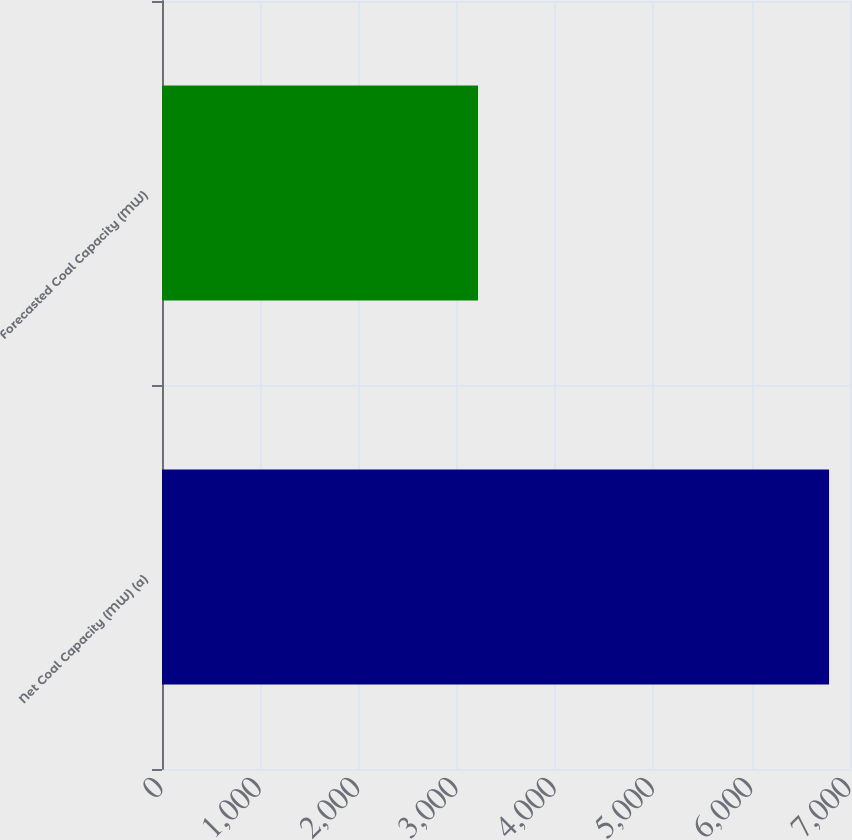Convert chart. <chart><loc_0><loc_0><loc_500><loc_500><bar_chart><fcel>Net Coal Capacity (MW) (a)<fcel>Forecasted Coal Capacity (MW)<nl><fcel>6787<fcel>3215<nl></chart> 